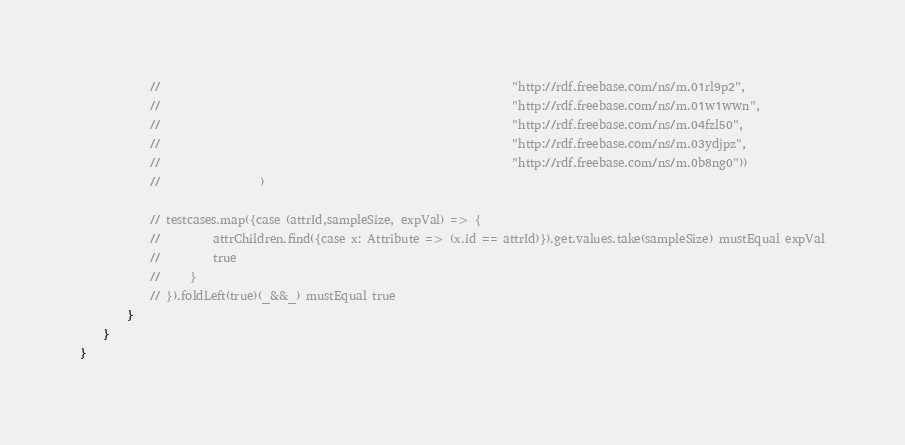<code> <loc_0><loc_0><loc_500><loc_500><_Scala_>            //                                                            "http://rdf.freebase.com/ns/m.01rl9p2", 
            //                                                            "http://rdf.freebase.com/ns/m.01w1wwn", 
            //                                                            "http://rdf.freebase.com/ns/m.04fzl50", 
            //                                                            "http://rdf.freebase.com/ns/m.03ydjpz", 
            //                                                            "http://rdf.freebase.com/ns/m.0b8ng0"))
            //                 )

            // testcases.map({case (attrId,sampleSize, expVal) => {
            //         attrChildren.find({case x: Attribute => (x.id == attrId)}).get.values.take(sampleSize) mustEqual expVal
            //         true
            //     }
            // }).foldLeft(true)(_&&_) mustEqual true
        }
    }
}</code> 